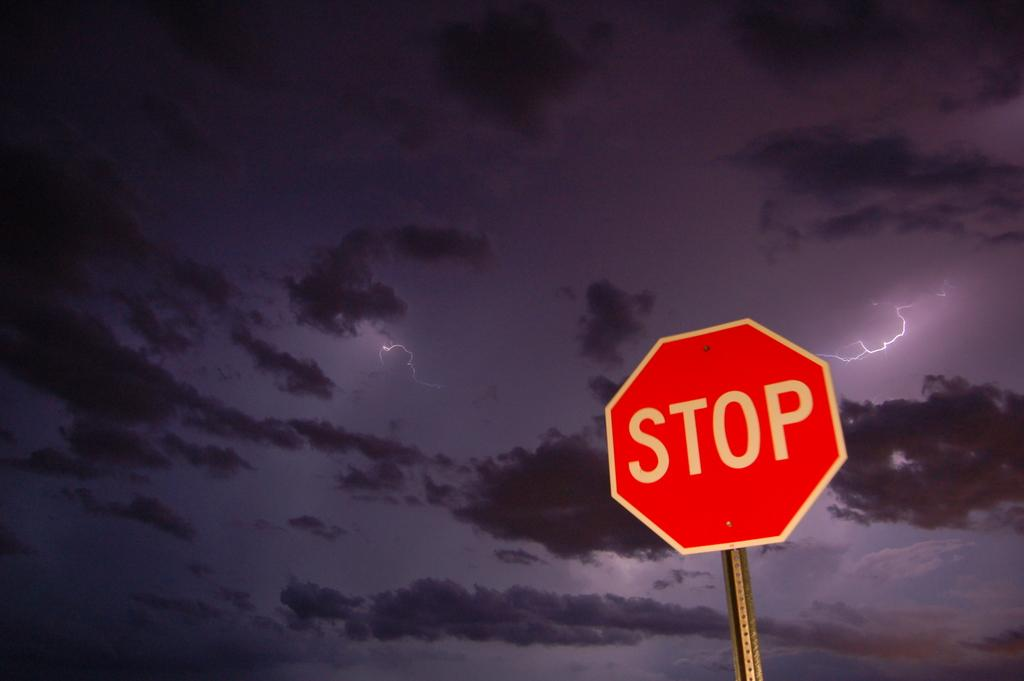<image>
Relay a brief, clear account of the picture shown. An dark clear sky with a few puffy clouds and a couple lighting bolts and also with a stop sign showing in the night sky. 